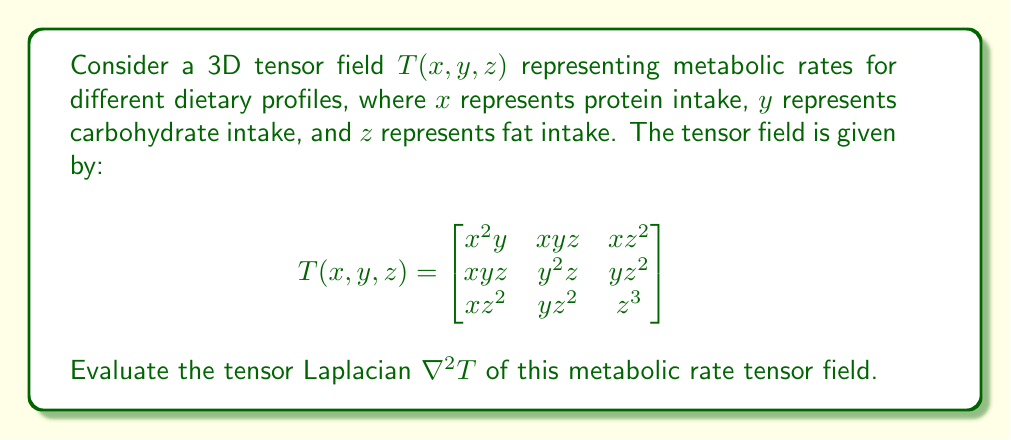Show me your answer to this math problem. To evaluate the tensor Laplacian $\nabla^2 T$, we need to follow these steps:

1) The tensor Laplacian is defined as the sum of the second partial derivatives with respect to each variable:

   $$\nabla^2 T = \frac{\partial^2 T}{\partial x^2} + \frac{\partial^2 T}{\partial y^2} + \frac{\partial^2 T}{\partial z^2}$$

2) Let's calculate each term separately:

   a) $\frac{\partial^2 T}{\partial x^2}$:
      First, $\frac{\partial T}{\partial x} = \begin{bmatrix}
      2xy & yz & z^2 \\
      yz & 0 & 0 \\
      z^2 & 0 & 0
      \end{bmatrix}$

      Then, $\frac{\partial^2 T}{\partial x^2} = \begin{bmatrix}
      2y & 0 & 0 \\
      0 & 0 & 0 \\
      0 & 0 & 0
      \end{bmatrix}$

   b) $\frac{\partial^2 T}{\partial y^2}$:
      First, $\frac{\partial T}{\partial y} = \begin{bmatrix}
      x^2 & xz & 0 \\
      xz & 2yz & z^2 \\
      0 & z^2 & 0
      \end{bmatrix}$

      Then, $\frac{\partial^2 T}{\partial y^2} = \begin{bmatrix}
      0 & 0 & 0 \\
      0 & 2z & 0 \\
      0 & 0 & 0
      \end{bmatrix}$

   c) $\frac{\partial^2 T}{\partial z^2}$:
      First, $\frac{\partial T}{\partial z} = \begin{bmatrix}
      0 & xy & 2xz \\
      xy & y^2 & 2yz \\
      2xz & 2yz & 3z^2
      \end{bmatrix}$

      Then, $\frac{\partial^2 T}{\partial z^2} = \begin{bmatrix}
      0 & 0 & 2x \\
      0 & 0 & 2y \\
      2x & 2y & 6z
      \end{bmatrix}$

3) Now, we sum these three matrices to get the tensor Laplacian:

   $$\nabla^2 T = \frac{\partial^2 T}{\partial x^2} + \frac{\partial^2 T}{\partial y^2} + \frac{\partial^2 T}{\partial z^2}$$

   $$= \begin{bmatrix}
   2y & 0 & 0 \\
   0 & 0 & 0 \\
   0 & 0 & 0
   \end{bmatrix} + \begin{bmatrix}
   0 & 0 & 0 \\
   0 & 2z & 0 \\
   0 & 0 & 0
   \end{bmatrix} + \begin{bmatrix}
   0 & 0 & 2x \\
   0 & 0 & 2y \\
   2x & 2y & 6z
   \end{bmatrix}$$

   $$= \begin{bmatrix}
   2y & 0 & 2x \\
   0 & 2z & 2y \\
   2x & 2y & 6z
   \end{bmatrix}$$
Answer: $$\nabla^2 T = \begin{bmatrix}
2y & 0 & 2x \\
0 & 2z & 2y \\
2x & 2y & 6z
\end{bmatrix}$$ 